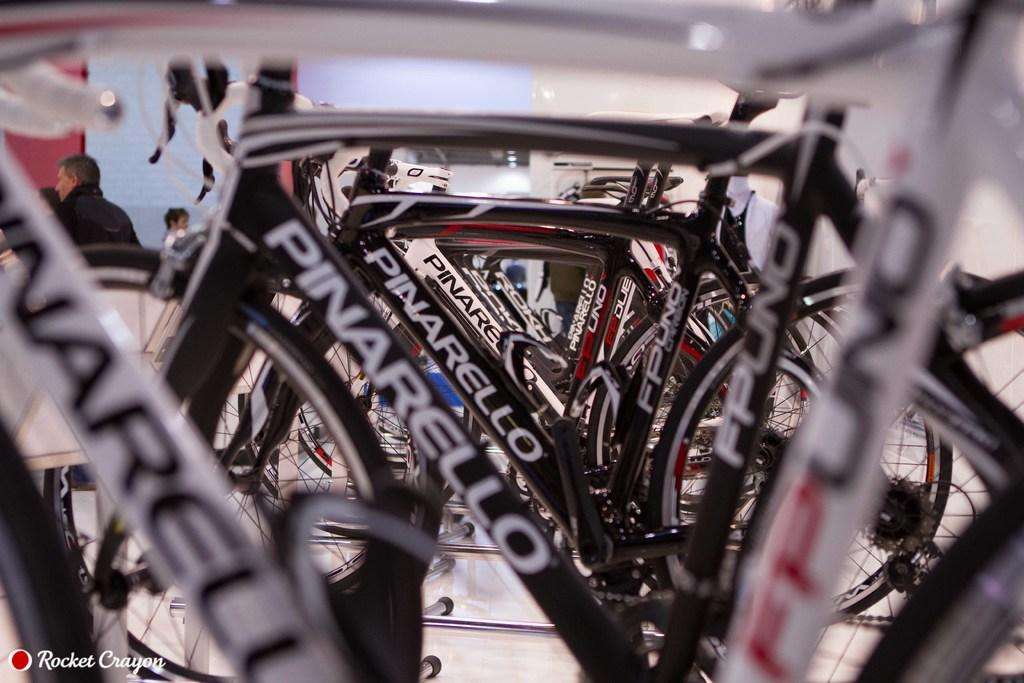What type of vehicles are in the image? There are cycles in the image. How are the cycles arranged? The cycles are arranged in a row. What can be seen on the left side of the image? There are people gathered on the left side of the image. What color is the wall visible in the background? There is a pink wall in the background of the image. What type of salt can be seen falling from the sky in the image? There is no salt falling from the sky in the image; it does not depict any weather conditions or natural phenomena. 